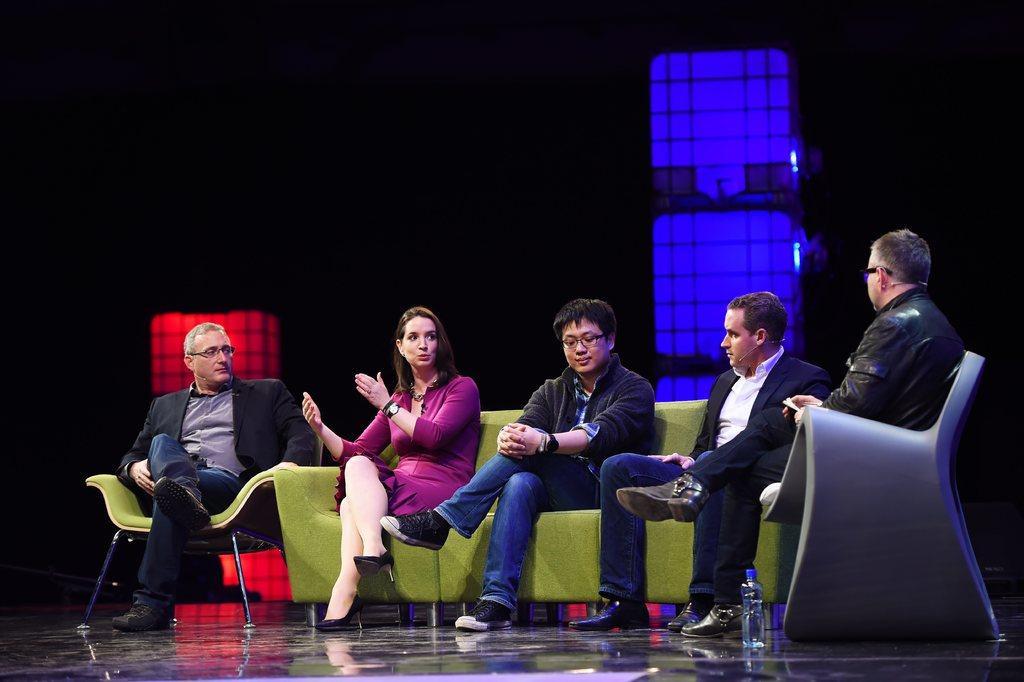How would you summarize this image in a sentence or two? On the left side a man is sitting on the chair, he wore coat, trouser, shoes. Beside him a beautiful girl is sitting on the green color sofa, she wore dress, shoes. Beside her 3 men are sitting on the sofas and listening to her. 